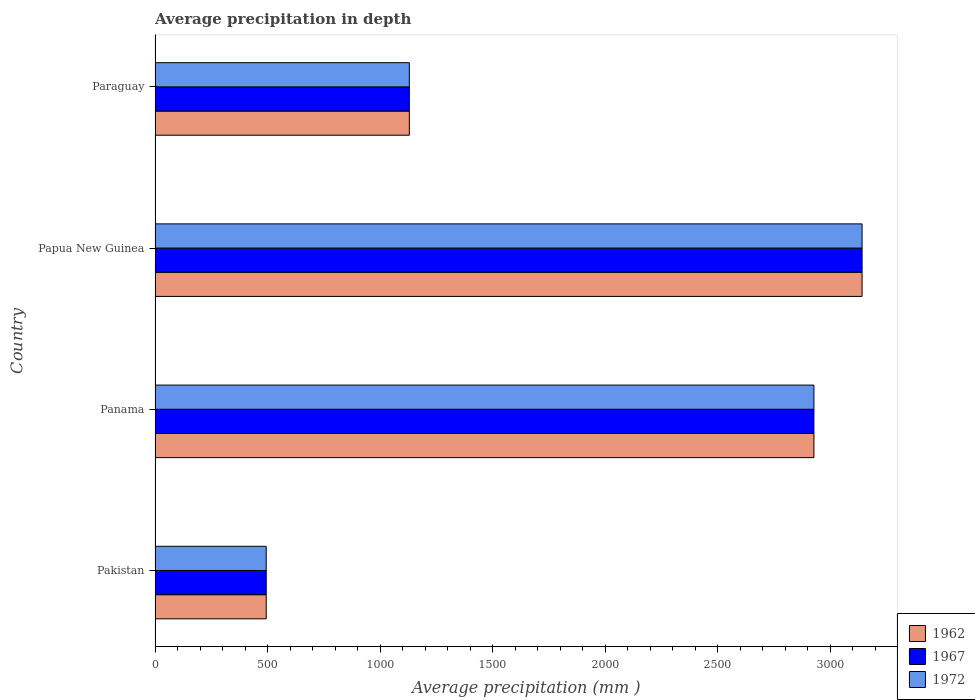How many different coloured bars are there?
Offer a very short reply. 3. Are the number of bars per tick equal to the number of legend labels?
Give a very brief answer. Yes. Are the number of bars on each tick of the Y-axis equal?
Ensure brevity in your answer.  Yes. What is the label of the 3rd group of bars from the top?
Your answer should be compact. Panama. In how many cases, is the number of bars for a given country not equal to the number of legend labels?
Your answer should be compact. 0. What is the average precipitation in 1967 in Panama?
Ensure brevity in your answer.  2928. Across all countries, what is the maximum average precipitation in 1962?
Provide a short and direct response. 3142. Across all countries, what is the minimum average precipitation in 1962?
Provide a succinct answer. 494. In which country was the average precipitation in 1962 maximum?
Your answer should be compact. Papua New Guinea. In which country was the average precipitation in 1962 minimum?
Offer a terse response. Pakistan. What is the total average precipitation in 1967 in the graph?
Ensure brevity in your answer.  7694. What is the difference between the average precipitation in 1967 in Panama and that in Papua New Guinea?
Ensure brevity in your answer.  -214. What is the difference between the average precipitation in 1972 in Panama and the average precipitation in 1967 in Paraguay?
Ensure brevity in your answer.  1798. What is the average average precipitation in 1972 per country?
Offer a terse response. 1923.5. What is the difference between the average precipitation in 1962 and average precipitation in 1967 in Panama?
Your response must be concise. 0. What is the ratio of the average precipitation in 1967 in Panama to that in Paraguay?
Offer a terse response. 2.59. Is the difference between the average precipitation in 1962 in Panama and Paraguay greater than the difference between the average precipitation in 1967 in Panama and Paraguay?
Make the answer very short. No. What is the difference between the highest and the second highest average precipitation in 1962?
Give a very brief answer. 214. What is the difference between the highest and the lowest average precipitation in 1967?
Give a very brief answer. 2648. Is the sum of the average precipitation in 1972 in Pakistan and Panama greater than the maximum average precipitation in 1962 across all countries?
Provide a short and direct response. Yes. What does the 2nd bar from the top in Papua New Guinea represents?
Offer a terse response. 1967. Is it the case that in every country, the sum of the average precipitation in 1972 and average precipitation in 1967 is greater than the average precipitation in 1962?
Offer a very short reply. Yes. How many countries are there in the graph?
Offer a terse response. 4. Are the values on the major ticks of X-axis written in scientific E-notation?
Ensure brevity in your answer.  No. Does the graph contain grids?
Make the answer very short. No. How are the legend labels stacked?
Provide a short and direct response. Vertical. What is the title of the graph?
Give a very brief answer. Average precipitation in depth. Does "2009" appear as one of the legend labels in the graph?
Offer a very short reply. No. What is the label or title of the X-axis?
Give a very brief answer. Average precipitation (mm ). What is the Average precipitation (mm ) in 1962 in Pakistan?
Ensure brevity in your answer.  494. What is the Average precipitation (mm ) in 1967 in Pakistan?
Keep it short and to the point. 494. What is the Average precipitation (mm ) of 1972 in Pakistan?
Give a very brief answer. 494. What is the Average precipitation (mm ) of 1962 in Panama?
Ensure brevity in your answer.  2928. What is the Average precipitation (mm ) in 1967 in Panama?
Give a very brief answer. 2928. What is the Average precipitation (mm ) in 1972 in Panama?
Offer a terse response. 2928. What is the Average precipitation (mm ) of 1962 in Papua New Guinea?
Your answer should be very brief. 3142. What is the Average precipitation (mm ) of 1967 in Papua New Guinea?
Give a very brief answer. 3142. What is the Average precipitation (mm ) of 1972 in Papua New Guinea?
Provide a short and direct response. 3142. What is the Average precipitation (mm ) in 1962 in Paraguay?
Your response must be concise. 1130. What is the Average precipitation (mm ) of 1967 in Paraguay?
Make the answer very short. 1130. What is the Average precipitation (mm ) in 1972 in Paraguay?
Keep it short and to the point. 1130. Across all countries, what is the maximum Average precipitation (mm ) of 1962?
Offer a very short reply. 3142. Across all countries, what is the maximum Average precipitation (mm ) of 1967?
Your answer should be compact. 3142. Across all countries, what is the maximum Average precipitation (mm ) in 1972?
Give a very brief answer. 3142. Across all countries, what is the minimum Average precipitation (mm ) in 1962?
Your answer should be compact. 494. Across all countries, what is the minimum Average precipitation (mm ) of 1967?
Keep it short and to the point. 494. Across all countries, what is the minimum Average precipitation (mm ) of 1972?
Your answer should be compact. 494. What is the total Average precipitation (mm ) in 1962 in the graph?
Keep it short and to the point. 7694. What is the total Average precipitation (mm ) of 1967 in the graph?
Offer a terse response. 7694. What is the total Average precipitation (mm ) in 1972 in the graph?
Offer a terse response. 7694. What is the difference between the Average precipitation (mm ) of 1962 in Pakistan and that in Panama?
Make the answer very short. -2434. What is the difference between the Average precipitation (mm ) of 1967 in Pakistan and that in Panama?
Keep it short and to the point. -2434. What is the difference between the Average precipitation (mm ) of 1972 in Pakistan and that in Panama?
Your answer should be compact. -2434. What is the difference between the Average precipitation (mm ) of 1962 in Pakistan and that in Papua New Guinea?
Your answer should be compact. -2648. What is the difference between the Average precipitation (mm ) in 1967 in Pakistan and that in Papua New Guinea?
Ensure brevity in your answer.  -2648. What is the difference between the Average precipitation (mm ) in 1972 in Pakistan and that in Papua New Guinea?
Provide a succinct answer. -2648. What is the difference between the Average precipitation (mm ) of 1962 in Pakistan and that in Paraguay?
Your answer should be compact. -636. What is the difference between the Average precipitation (mm ) in 1967 in Pakistan and that in Paraguay?
Keep it short and to the point. -636. What is the difference between the Average precipitation (mm ) in 1972 in Pakistan and that in Paraguay?
Your answer should be very brief. -636. What is the difference between the Average precipitation (mm ) in 1962 in Panama and that in Papua New Guinea?
Offer a very short reply. -214. What is the difference between the Average precipitation (mm ) of 1967 in Panama and that in Papua New Guinea?
Make the answer very short. -214. What is the difference between the Average precipitation (mm ) in 1972 in Panama and that in Papua New Guinea?
Provide a succinct answer. -214. What is the difference between the Average precipitation (mm ) in 1962 in Panama and that in Paraguay?
Keep it short and to the point. 1798. What is the difference between the Average precipitation (mm ) of 1967 in Panama and that in Paraguay?
Offer a terse response. 1798. What is the difference between the Average precipitation (mm ) in 1972 in Panama and that in Paraguay?
Provide a short and direct response. 1798. What is the difference between the Average precipitation (mm ) in 1962 in Papua New Guinea and that in Paraguay?
Offer a terse response. 2012. What is the difference between the Average precipitation (mm ) in 1967 in Papua New Guinea and that in Paraguay?
Offer a very short reply. 2012. What is the difference between the Average precipitation (mm ) of 1972 in Papua New Guinea and that in Paraguay?
Keep it short and to the point. 2012. What is the difference between the Average precipitation (mm ) in 1962 in Pakistan and the Average precipitation (mm ) in 1967 in Panama?
Your answer should be very brief. -2434. What is the difference between the Average precipitation (mm ) of 1962 in Pakistan and the Average precipitation (mm ) of 1972 in Panama?
Make the answer very short. -2434. What is the difference between the Average precipitation (mm ) in 1967 in Pakistan and the Average precipitation (mm ) in 1972 in Panama?
Ensure brevity in your answer.  -2434. What is the difference between the Average precipitation (mm ) of 1962 in Pakistan and the Average precipitation (mm ) of 1967 in Papua New Guinea?
Your answer should be very brief. -2648. What is the difference between the Average precipitation (mm ) in 1962 in Pakistan and the Average precipitation (mm ) in 1972 in Papua New Guinea?
Your answer should be compact. -2648. What is the difference between the Average precipitation (mm ) of 1967 in Pakistan and the Average precipitation (mm ) of 1972 in Papua New Guinea?
Offer a terse response. -2648. What is the difference between the Average precipitation (mm ) of 1962 in Pakistan and the Average precipitation (mm ) of 1967 in Paraguay?
Offer a terse response. -636. What is the difference between the Average precipitation (mm ) of 1962 in Pakistan and the Average precipitation (mm ) of 1972 in Paraguay?
Provide a succinct answer. -636. What is the difference between the Average precipitation (mm ) of 1967 in Pakistan and the Average precipitation (mm ) of 1972 in Paraguay?
Offer a very short reply. -636. What is the difference between the Average precipitation (mm ) of 1962 in Panama and the Average precipitation (mm ) of 1967 in Papua New Guinea?
Offer a very short reply. -214. What is the difference between the Average precipitation (mm ) of 1962 in Panama and the Average precipitation (mm ) of 1972 in Papua New Guinea?
Keep it short and to the point. -214. What is the difference between the Average precipitation (mm ) of 1967 in Panama and the Average precipitation (mm ) of 1972 in Papua New Guinea?
Your answer should be compact. -214. What is the difference between the Average precipitation (mm ) of 1962 in Panama and the Average precipitation (mm ) of 1967 in Paraguay?
Offer a terse response. 1798. What is the difference between the Average precipitation (mm ) of 1962 in Panama and the Average precipitation (mm ) of 1972 in Paraguay?
Ensure brevity in your answer.  1798. What is the difference between the Average precipitation (mm ) in 1967 in Panama and the Average precipitation (mm ) in 1972 in Paraguay?
Ensure brevity in your answer.  1798. What is the difference between the Average precipitation (mm ) in 1962 in Papua New Guinea and the Average precipitation (mm ) in 1967 in Paraguay?
Offer a terse response. 2012. What is the difference between the Average precipitation (mm ) of 1962 in Papua New Guinea and the Average precipitation (mm ) of 1972 in Paraguay?
Your answer should be compact. 2012. What is the difference between the Average precipitation (mm ) in 1967 in Papua New Guinea and the Average precipitation (mm ) in 1972 in Paraguay?
Offer a terse response. 2012. What is the average Average precipitation (mm ) of 1962 per country?
Ensure brevity in your answer.  1923.5. What is the average Average precipitation (mm ) in 1967 per country?
Your response must be concise. 1923.5. What is the average Average precipitation (mm ) of 1972 per country?
Keep it short and to the point. 1923.5. What is the difference between the Average precipitation (mm ) of 1967 and Average precipitation (mm ) of 1972 in Pakistan?
Offer a terse response. 0. What is the difference between the Average precipitation (mm ) of 1962 and Average precipitation (mm ) of 1967 in Panama?
Provide a succinct answer. 0. What is the difference between the Average precipitation (mm ) of 1967 and Average precipitation (mm ) of 1972 in Panama?
Make the answer very short. 0. What is the difference between the Average precipitation (mm ) in 1967 and Average precipitation (mm ) in 1972 in Paraguay?
Provide a short and direct response. 0. What is the ratio of the Average precipitation (mm ) in 1962 in Pakistan to that in Panama?
Your answer should be very brief. 0.17. What is the ratio of the Average precipitation (mm ) of 1967 in Pakistan to that in Panama?
Your response must be concise. 0.17. What is the ratio of the Average precipitation (mm ) in 1972 in Pakistan to that in Panama?
Ensure brevity in your answer.  0.17. What is the ratio of the Average precipitation (mm ) in 1962 in Pakistan to that in Papua New Guinea?
Ensure brevity in your answer.  0.16. What is the ratio of the Average precipitation (mm ) in 1967 in Pakistan to that in Papua New Guinea?
Keep it short and to the point. 0.16. What is the ratio of the Average precipitation (mm ) in 1972 in Pakistan to that in Papua New Guinea?
Your response must be concise. 0.16. What is the ratio of the Average precipitation (mm ) in 1962 in Pakistan to that in Paraguay?
Give a very brief answer. 0.44. What is the ratio of the Average precipitation (mm ) in 1967 in Pakistan to that in Paraguay?
Give a very brief answer. 0.44. What is the ratio of the Average precipitation (mm ) in 1972 in Pakistan to that in Paraguay?
Keep it short and to the point. 0.44. What is the ratio of the Average precipitation (mm ) of 1962 in Panama to that in Papua New Guinea?
Keep it short and to the point. 0.93. What is the ratio of the Average precipitation (mm ) of 1967 in Panama to that in Papua New Guinea?
Offer a very short reply. 0.93. What is the ratio of the Average precipitation (mm ) in 1972 in Panama to that in Papua New Guinea?
Keep it short and to the point. 0.93. What is the ratio of the Average precipitation (mm ) of 1962 in Panama to that in Paraguay?
Ensure brevity in your answer.  2.59. What is the ratio of the Average precipitation (mm ) in 1967 in Panama to that in Paraguay?
Your answer should be compact. 2.59. What is the ratio of the Average precipitation (mm ) of 1972 in Panama to that in Paraguay?
Make the answer very short. 2.59. What is the ratio of the Average precipitation (mm ) in 1962 in Papua New Guinea to that in Paraguay?
Offer a very short reply. 2.78. What is the ratio of the Average precipitation (mm ) of 1967 in Papua New Guinea to that in Paraguay?
Your answer should be very brief. 2.78. What is the ratio of the Average precipitation (mm ) of 1972 in Papua New Guinea to that in Paraguay?
Offer a very short reply. 2.78. What is the difference between the highest and the second highest Average precipitation (mm ) of 1962?
Your response must be concise. 214. What is the difference between the highest and the second highest Average precipitation (mm ) of 1967?
Give a very brief answer. 214. What is the difference between the highest and the second highest Average precipitation (mm ) of 1972?
Offer a terse response. 214. What is the difference between the highest and the lowest Average precipitation (mm ) in 1962?
Your answer should be very brief. 2648. What is the difference between the highest and the lowest Average precipitation (mm ) in 1967?
Your response must be concise. 2648. What is the difference between the highest and the lowest Average precipitation (mm ) of 1972?
Offer a very short reply. 2648. 